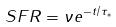Convert formula to latex. <formula><loc_0><loc_0><loc_500><loc_500>S F R = \nu e ^ { - t / \tau _ { * } }</formula> 